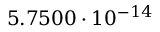<formula> <loc_0><loc_0><loc_500><loc_500>5 . 7 5 0 0 \cdot 1 0 ^ { - 1 4 }</formula> 